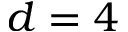Convert formula to latex. <formula><loc_0><loc_0><loc_500><loc_500>d = 4</formula> 